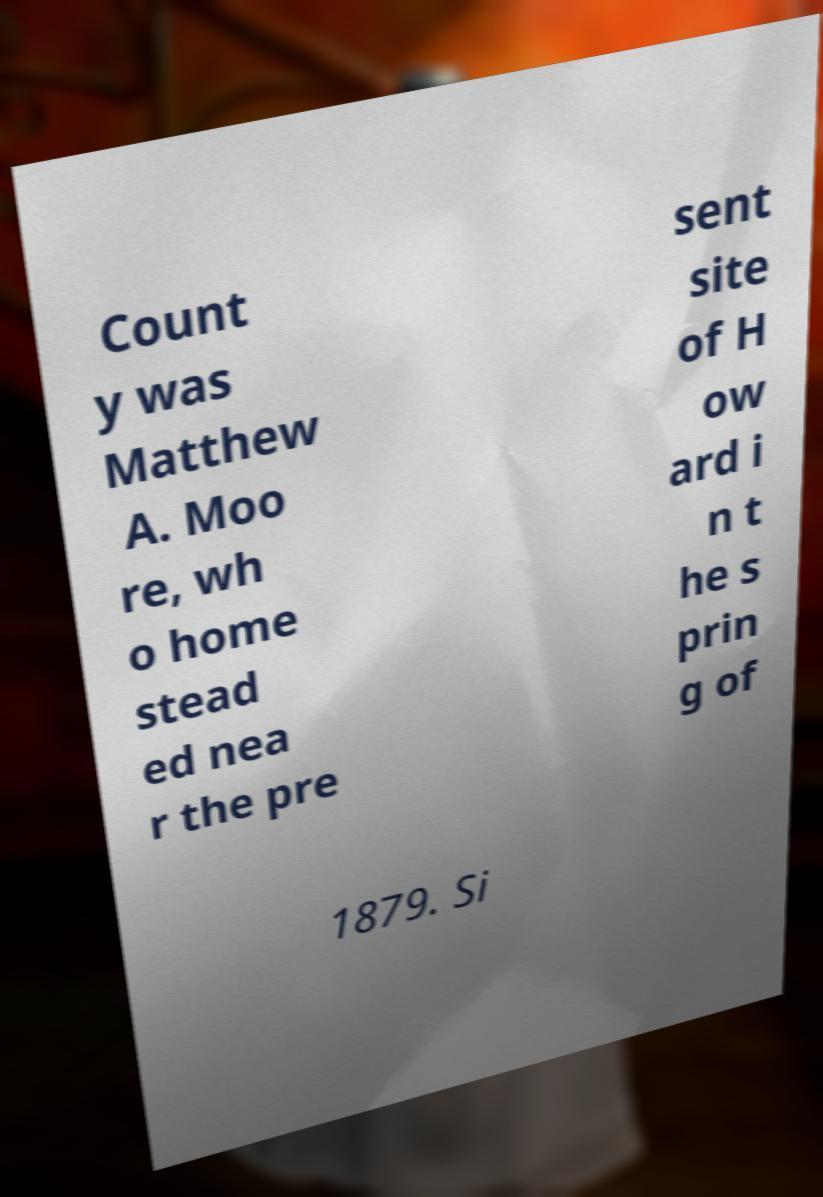Please read and relay the text visible in this image. What does it say? Count y was Matthew A. Moo re, wh o home stead ed nea r the pre sent site of H ow ard i n t he s prin g of 1879. Si 